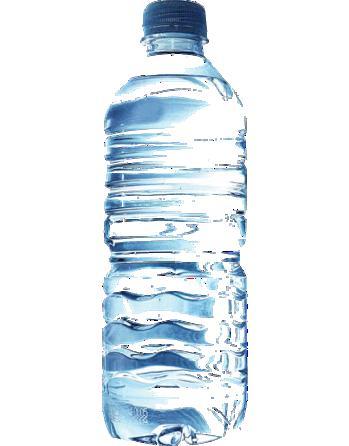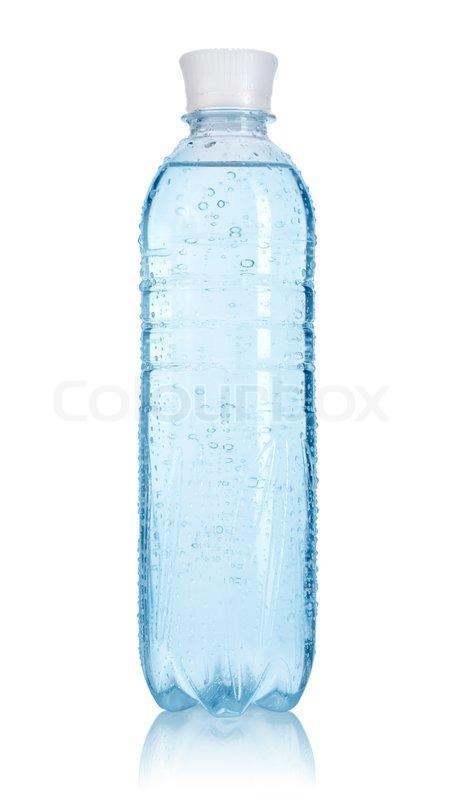The first image is the image on the left, the second image is the image on the right. For the images displayed, is the sentence "An image shows at least one filled water bottle with a blue lid and no label." factually correct? Answer yes or no. Yes. 